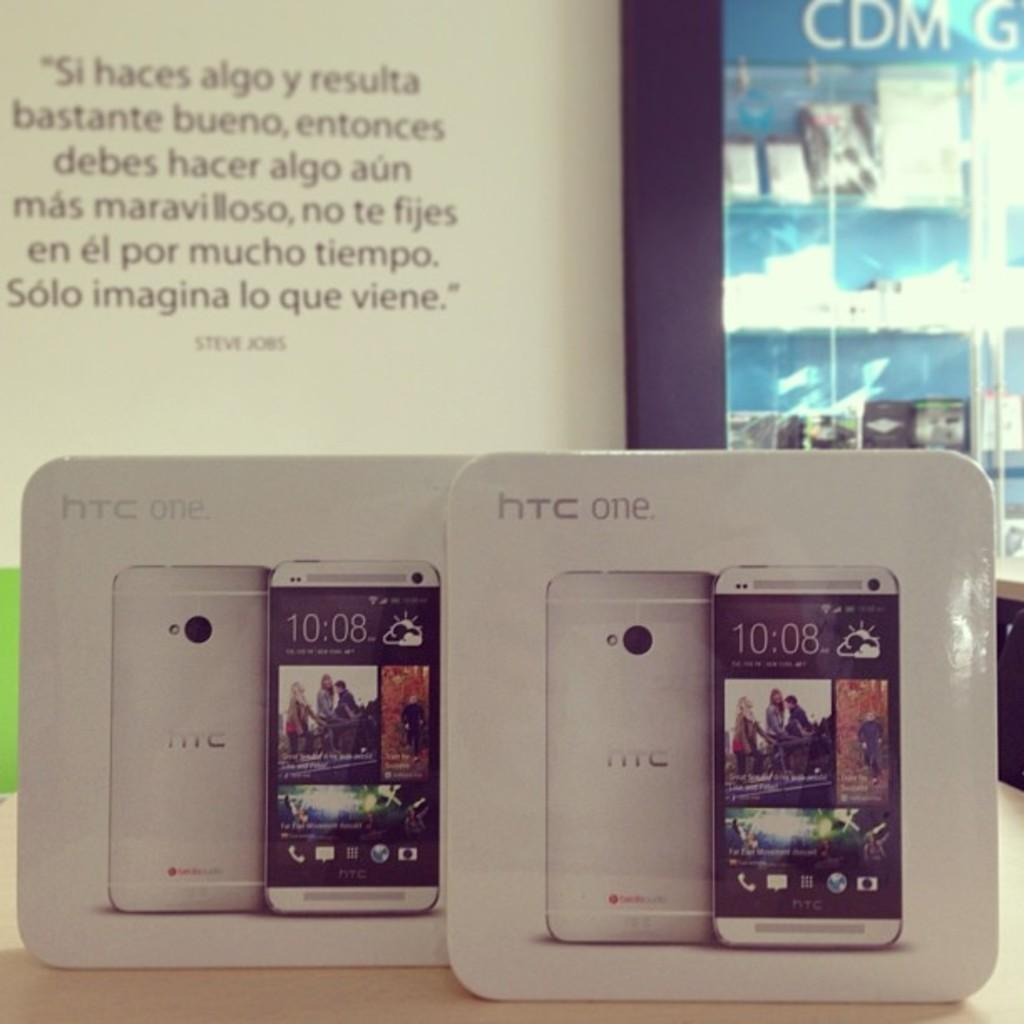Provide a one-sentence caption for the provided image. two HTC one phones are displayed in their boxes. 